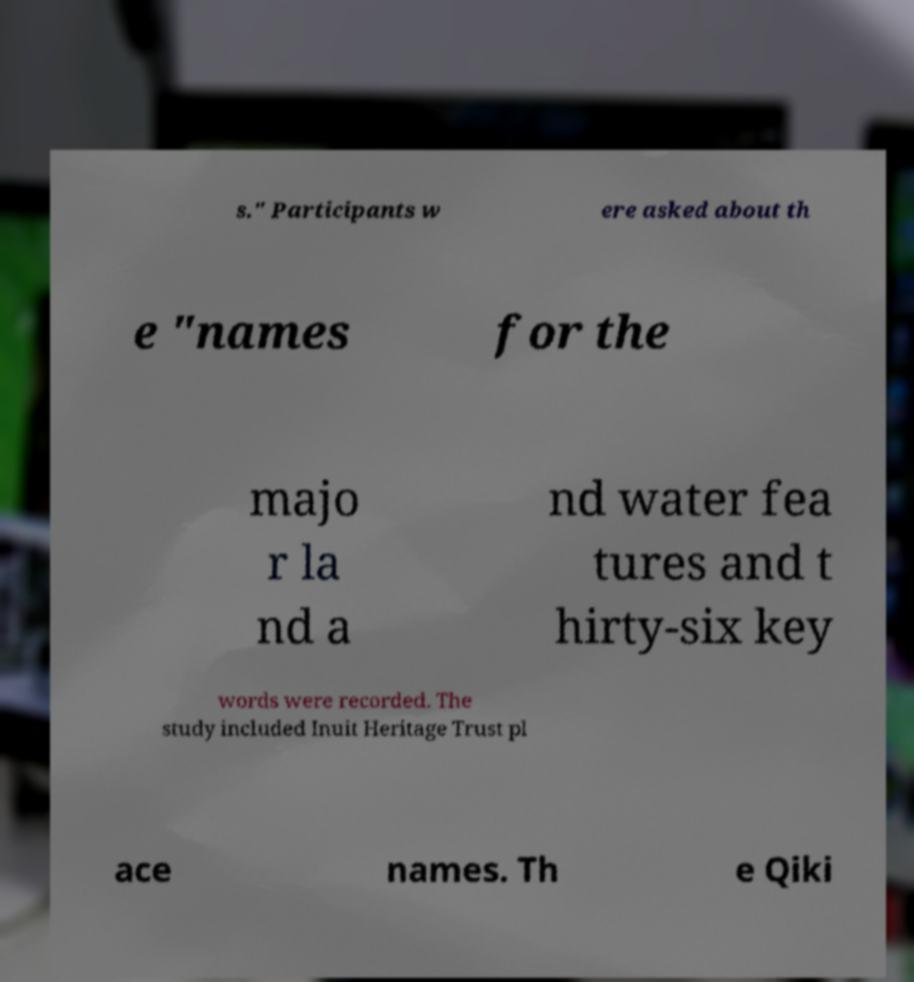Please read and relay the text visible in this image. What does it say? s." Participants w ere asked about th e "names for the majo r la nd a nd water fea tures and t hirty-six key words were recorded. The study included Inuit Heritage Trust pl ace names. Th e Qiki 